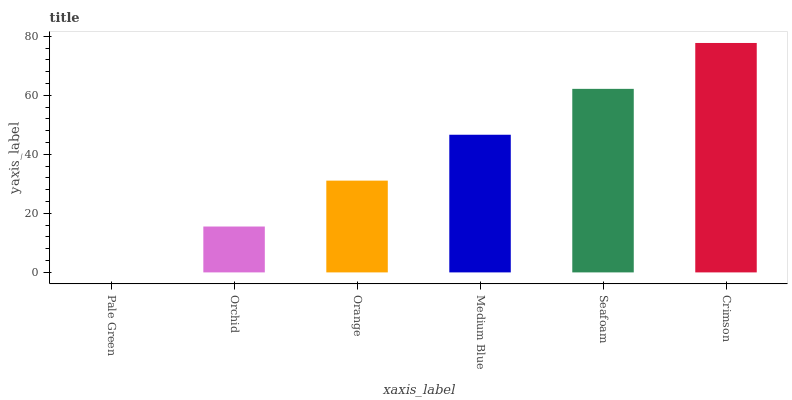Is Pale Green the minimum?
Answer yes or no. Yes. Is Crimson the maximum?
Answer yes or no. Yes. Is Orchid the minimum?
Answer yes or no. No. Is Orchid the maximum?
Answer yes or no. No. Is Orchid greater than Pale Green?
Answer yes or no. Yes. Is Pale Green less than Orchid?
Answer yes or no. Yes. Is Pale Green greater than Orchid?
Answer yes or no. No. Is Orchid less than Pale Green?
Answer yes or no. No. Is Medium Blue the high median?
Answer yes or no. Yes. Is Orange the low median?
Answer yes or no. Yes. Is Pale Green the high median?
Answer yes or no. No. Is Orchid the low median?
Answer yes or no. No. 